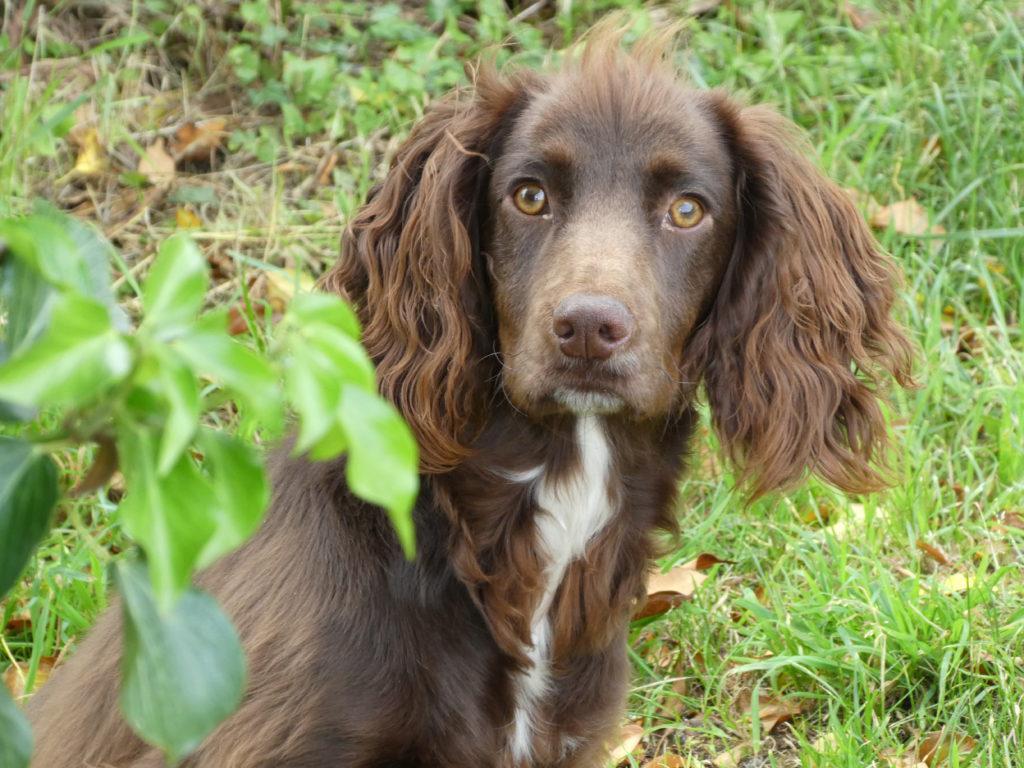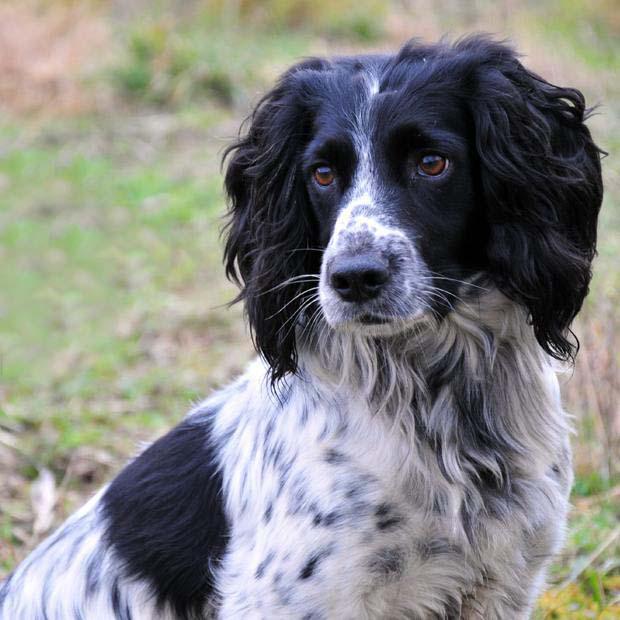The first image is the image on the left, the second image is the image on the right. Considering the images on both sides, is "At least one dog is wearing a dog tag on its collar." valid? Answer yes or no. No. The first image is the image on the left, the second image is the image on the right. Considering the images on both sides, is "The dog on the right has a charm dangling from its collar, and the dog on the left is sitting upright outdoors with something around its neck." valid? Answer yes or no. No. 